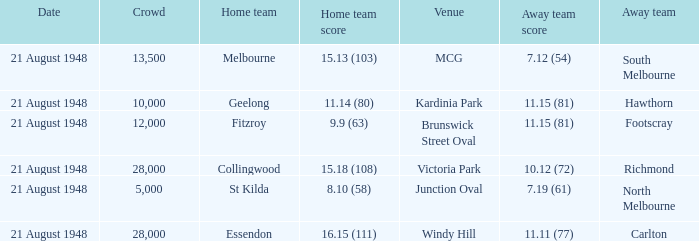If the Crowd is larger than 10,000 and the Away team score is 11.15 (81), what is the venue being played at? Brunswick Street Oval. 